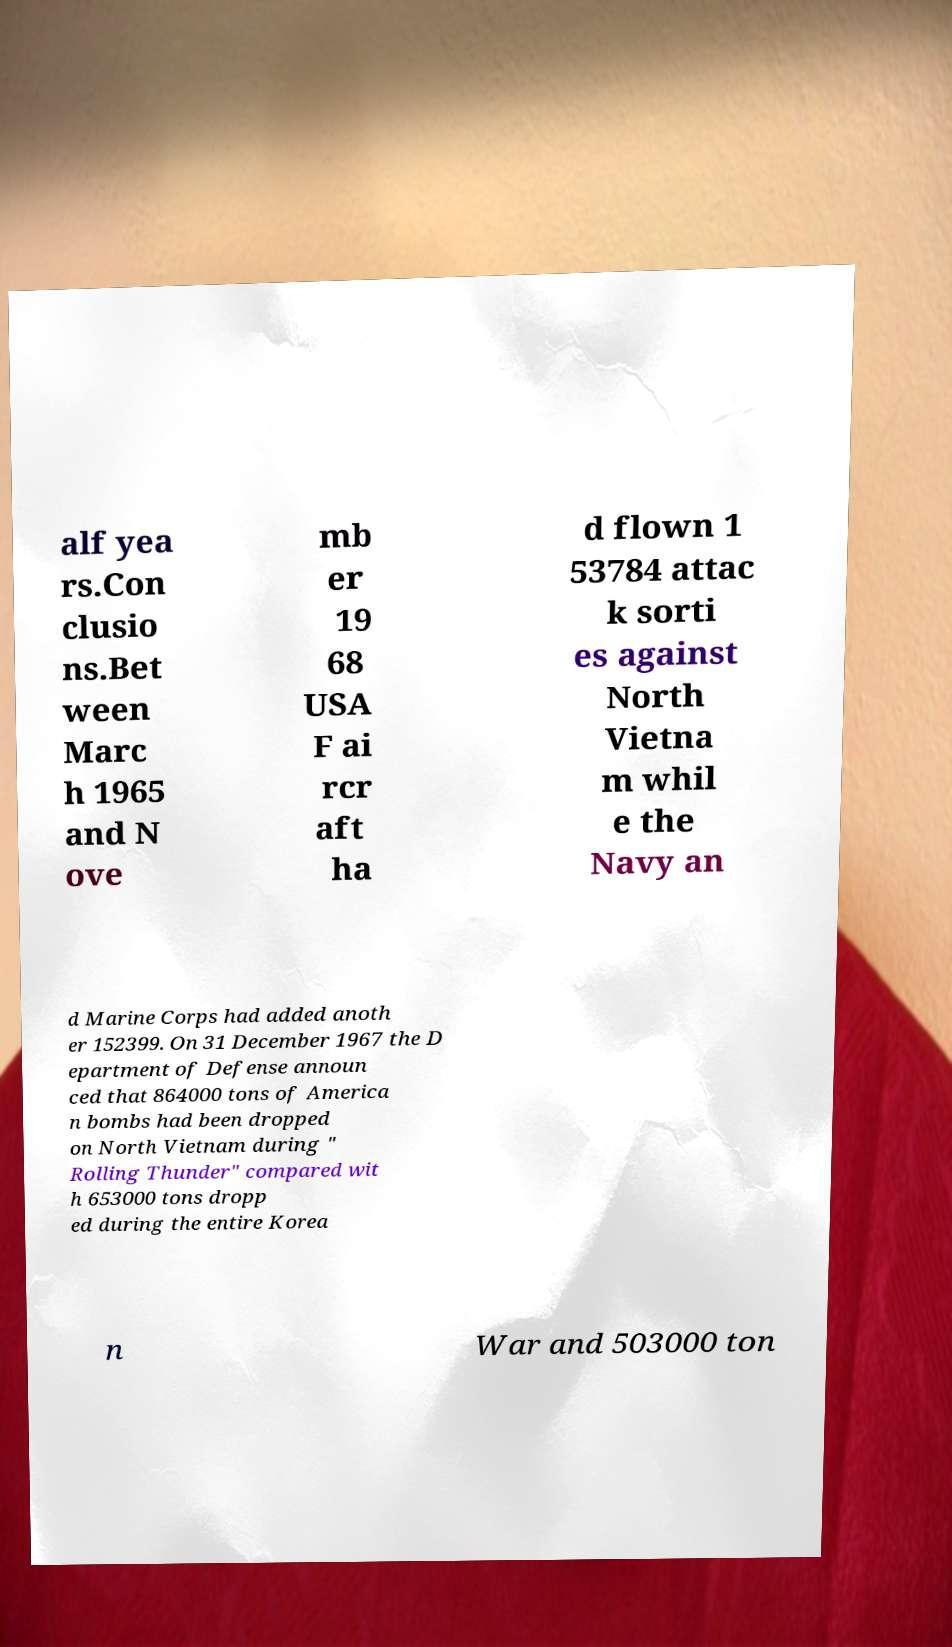Can you accurately transcribe the text from the provided image for me? alf yea rs.Con clusio ns.Bet ween Marc h 1965 and N ove mb er 19 68 USA F ai rcr aft ha d flown 1 53784 attac k sorti es against North Vietna m whil e the Navy an d Marine Corps had added anoth er 152399. On 31 December 1967 the D epartment of Defense announ ced that 864000 tons of America n bombs had been dropped on North Vietnam during " Rolling Thunder" compared wit h 653000 tons dropp ed during the entire Korea n War and 503000 ton 